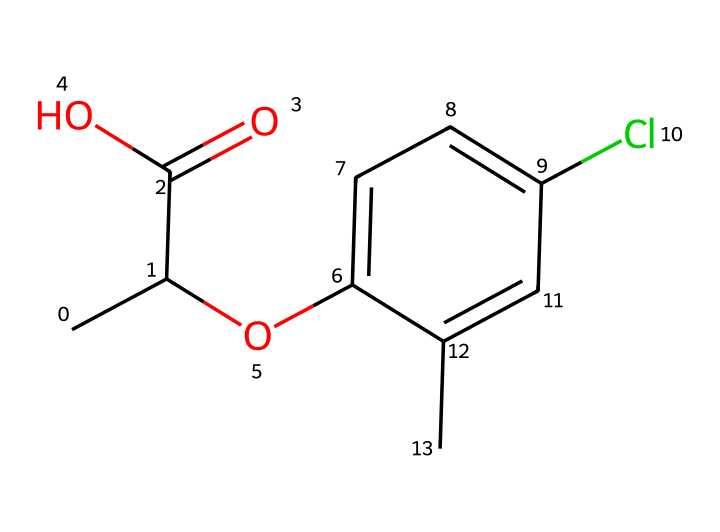What is the name of this herbicide? The SMILES representation corresponds to the chemical structure of mecoprop, a commonly used herbicide.
Answer: mecoprop How many carbon atoms are in mecoprop? By examining the SMILES, there are 10 carbon atoms indicated by 'C' symbols in the molecular formula.
Answer: 10 What type of functional group is present in mecoprop? The structure shows a carboxylic acid group (-COOH) indicated by the 'C(=O)O' part of the SMILES.
Answer: carboxylic acid How many chlorine atoms are in this chemical? There is one chlorine atom present in the structure, represented by 'Cl' in the SMILES.
Answer: 1 What is the total number of bonds in mecoprop? Counting the connections in the structure, there are 12 single bonds, 1 double bond (from the carbonyl group), leading to a total of 13 bonds.
Answer: 13 What makes mecoprop effective as a herbicide? Mecoprop affects plant growth by mimicking plant hormones, specifically disrupting their growth-regulating processes shown by the composition of its structure that influences plant physiology.
Answer: mimicking plant hormones Is mecoprop selective or non-selective herbicide? Mecoprop is considered a selective herbicide because it targets broadleaf weeds while sparing grasses, due to its structural similarity to natural growth regulators in plants.
Answer: selective 